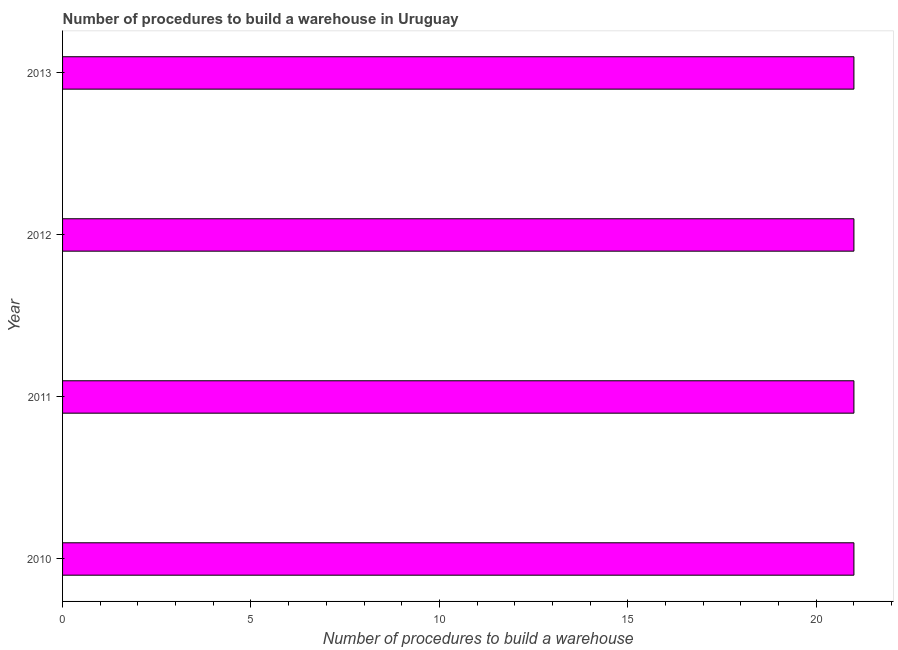Does the graph contain any zero values?
Give a very brief answer. No. What is the title of the graph?
Provide a short and direct response. Number of procedures to build a warehouse in Uruguay. What is the label or title of the X-axis?
Your answer should be very brief. Number of procedures to build a warehouse. What is the number of procedures to build a warehouse in 2013?
Provide a short and direct response. 21. Across all years, what is the minimum number of procedures to build a warehouse?
Provide a short and direct response. 21. In which year was the number of procedures to build a warehouse minimum?
Offer a terse response. 2010. What is the difference between the number of procedures to build a warehouse in 2011 and 2012?
Offer a terse response. 0. What is the median number of procedures to build a warehouse?
Provide a short and direct response. 21. Do a majority of the years between 2011 and 2012 (inclusive) have number of procedures to build a warehouse greater than 8 ?
Your answer should be compact. Yes. Is the number of procedures to build a warehouse in 2012 less than that in 2013?
Your response must be concise. No. Is the difference between the number of procedures to build a warehouse in 2012 and 2013 greater than the difference between any two years?
Provide a succinct answer. Yes. What is the difference between the highest and the second highest number of procedures to build a warehouse?
Ensure brevity in your answer.  0. What is the difference between the highest and the lowest number of procedures to build a warehouse?
Offer a terse response. 0. Are all the bars in the graph horizontal?
Your answer should be compact. Yes. How many years are there in the graph?
Make the answer very short. 4. What is the difference between two consecutive major ticks on the X-axis?
Provide a succinct answer. 5. Are the values on the major ticks of X-axis written in scientific E-notation?
Provide a succinct answer. No. What is the Number of procedures to build a warehouse of 2011?
Your response must be concise. 21. What is the Number of procedures to build a warehouse in 2013?
Provide a succinct answer. 21. What is the difference between the Number of procedures to build a warehouse in 2010 and 2012?
Provide a succinct answer. 0. What is the difference between the Number of procedures to build a warehouse in 2011 and 2012?
Your answer should be very brief. 0. What is the difference between the Number of procedures to build a warehouse in 2012 and 2013?
Your response must be concise. 0. What is the ratio of the Number of procedures to build a warehouse in 2010 to that in 2011?
Provide a succinct answer. 1. What is the ratio of the Number of procedures to build a warehouse in 2010 to that in 2013?
Keep it short and to the point. 1. What is the ratio of the Number of procedures to build a warehouse in 2011 to that in 2012?
Your answer should be compact. 1. What is the ratio of the Number of procedures to build a warehouse in 2012 to that in 2013?
Offer a very short reply. 1. 